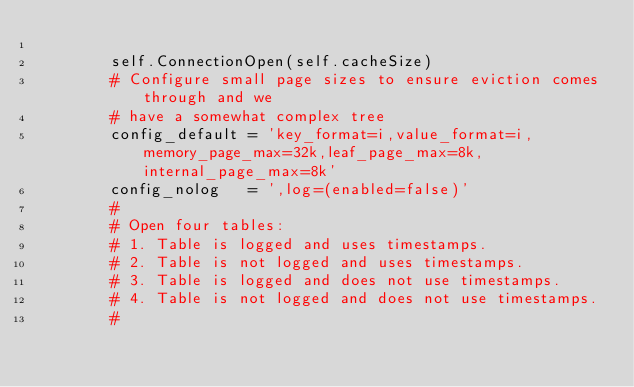Convert code to text. <code><loc_0><loc_0><loc_500><loc_500><_Python_>
        self.ConnectionOpen(self.cacheSize)
        # Configure small page sizes to ensure eviction comes through and we
        # have a somewhat complex tree
        config_default = 'key_format=i,value_format=i,memory_page_max=32k,leaf_page_max=8k,internal_page_max=8k'
        config_nolog   = ',log=(enabled=false)'
        #
        # Open four tables:
        # 1. Table is logged and uses timestamps.
        # 2. Table is not logged and uses timestamps.
        # 3. Table is logged and does not use timestamps.
        # 4. Table is not logged and does not use timestamps.
        #</code> 